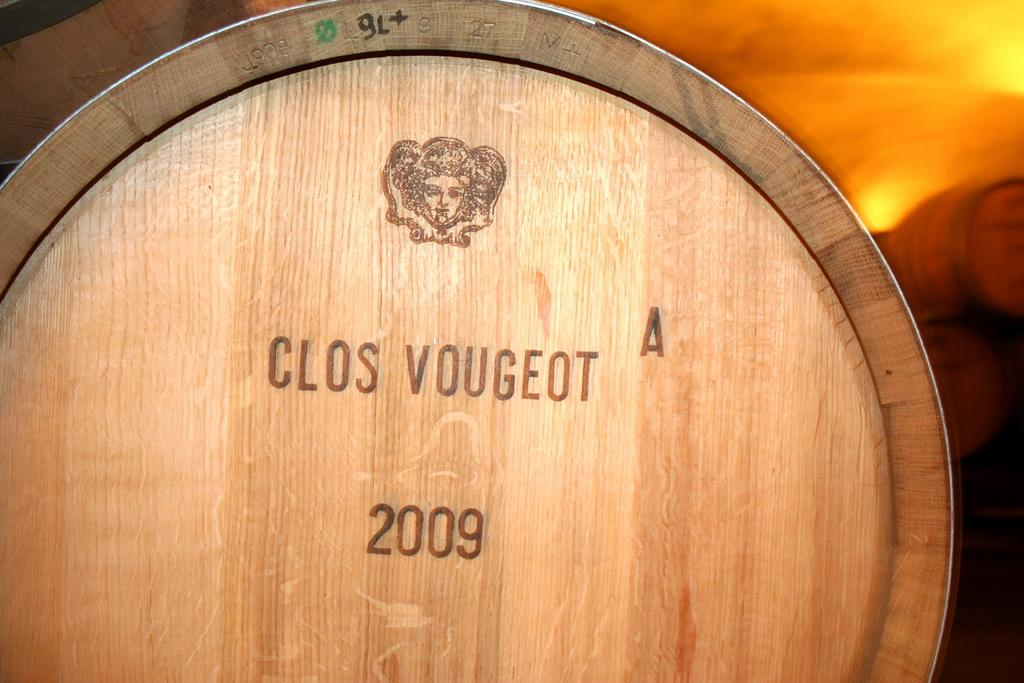<image>
Describe the image concisely. A cask of whiskey from Clos Vougeot from 2009 is on the ground. 